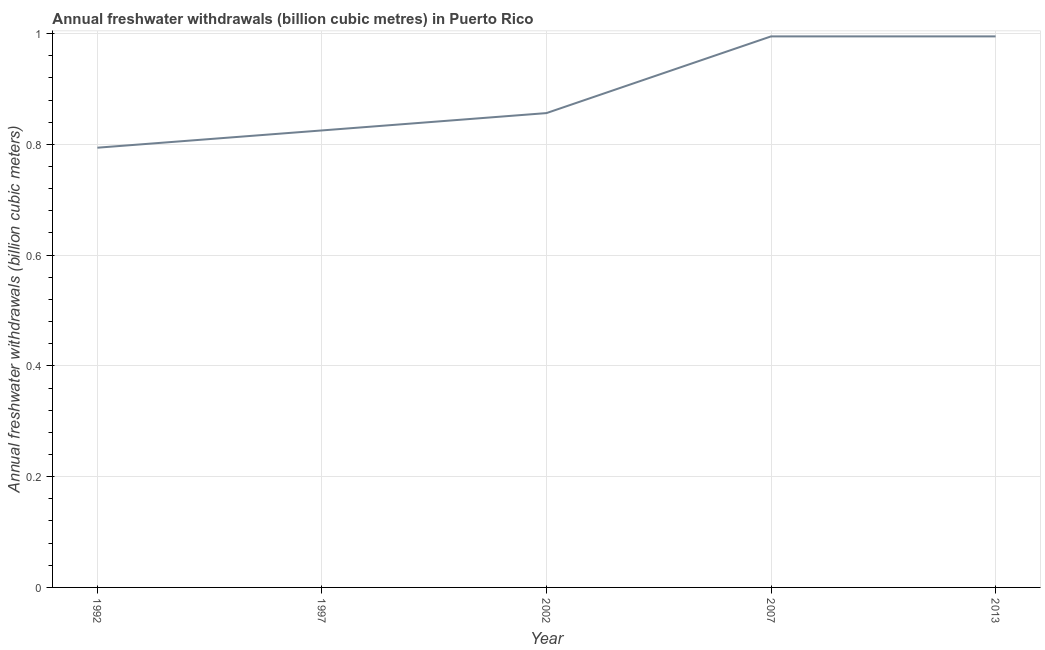What is the annual freshwater withdrawals in 1997?
Your answer should be very brief. 0.83. Across all years, what is the maximum annual freshwater withdrawals?
Offer a terse response. 0.99. Across all years, what is the minimum annual freshwater withdrawals?
Ensure brevity in your answer.  0.79. What is the sum of the annual freshwater withdrawals?
Give a very brief answer. 4.47. What is the difference between the annual freshwater withdrawals in 1992 and 2013?
Offer a terse response. -0.2. What is the average annual freshwater withdrawals per year?
Offer a very short reply. 0.89. What is the median annual freshwater withdrawals?
Offer a terse response. 0.86. In how many years, is the annual freshwater withdrawals greater than 0.7200000000000001 billion cubic meters?
Your answer should be very brief. 5. Do a majority of the years between 2013 and 2002 (inclusive) have annual freshwater withdrawals greater than 0.8400000000000001 billion cubic meters?
Offer a terse response. No. What is the ratio of the annual freshwater withdrawals in 1992 to that in 2013?
Give a very brief answer. 0.8. Is the annual freshwater withdrawals in 1997 less than that in 2002?
Your answer should be very brief. Yes. What is the difference between the highest and the second highest annual freshwater withdrawals?
Your response must be concise. 0. Is the sum of the annual freshwater withdrawals in 1992 and 2002 greater than the maximum annual freshwater withdrawals across all years?
Your answer should be very brief. Yes. What is the difference between the highest and the lowest annual freshwater withdrawals?
Keep it short and to the point. 0.2. In how many years, is the annual freshwater withdrawals greater than the average annual freshwater withdrawals taken over all years?
Your response must be concise. 2. Does the annual freshwater withdrawals monotonically increase over the years?
Your answer should be very brief. No. How many lines are there?
Offer a very short reply. 1. Does the graph contain any zero values?
Ensure brevity in your answer.  No. What is the title of the graph?
Provide a short and direct response. Annual freshwater withdrawals (billion cubic metres) in Puerto Rico. What is the label or title of the X-axis?
Make the answer very short. Year. What is the label or title of the Y-axis?
Give a very brief answer. Annual freshwater withdrawals (billion cubic meters). What is the Annual freshwater withdrawals (billion cubic meters) of 1992?
Ensure brevity in your answer.  0.79. What is the Annual freshwater withdrawals (billion cubic meters) in 1997?
Give a very brief answer. 0.83. What is the Annual freshwater withdrawals (billion cubic meters) of 2002?
Provide a succinct answer. 0.86. What is the Annual freshwater withdrawals (billion cubic meters) of 2007?
Your response must be concise. 0.99. What is the difference between the Annual freshwater withdrawals (billion cubic meters) in 1992 and 1997?
Ensure brevity in your answer.  -0.03. What is the difference between the Annual freshwater withdrawals (billion cubic meters) in 1992 and 2002?
Offer a terse response. -0.06. What is the difference between the Annual freshwater withdrawals (billion cubic meters) in 1992 and 2007?
Your answer should be compact. -0.2. What is the difference between the Annual freshwater withdrawals (billion cubic meters) in 1992 and 2013?
Provide a short and direct response. -0.2. What is the difference between the Annual freshwater withdrawals (billion cubic meters) in 1997 and 2002?
Your answer should be compact. -0.03. What is the difference between the Annual freshwater withdrawals (billion cubic meters) in 1997 and 2007?
Offer a very short reply. -0.17. What is the difference between the Annual freshwater withdrawals (billion cubic meters) in 1997 and 2013?
Make the answer very short. -0.17. What is the difference between the Annual freshwater withdrawals (billion cubic meters) in 2002 and 2007?
Your answer should be compact. -0.14. What is the difference between the Annual freshwater withdrawals (billion cubic meters) in 2002 and 2013?
Offer a terse response. -0.14. What is the difference between the Annual freshwater withdrawals (billion cubic meters) in 2007 and 2013?
Give a very brief answer. 0. What is the ratio of the Annual freshwater withdrawals (billion cubic meters) in 1992 to that in 1997?
Offer a terse response. 0.96. What is the ratio of the Annual freshwater withdrawals (billion cubic meters) in 1992 to that in 2002?
Your response must be concise. 0.93. What is the ratio of the Annual freshwater withdrawals (billion cubic meters) in 1992 to that in 2007?
Provide a succinct answer. 0.8. What is the ratio of the Annual freshwater withdrawals (billion cubic meters) in 1992 to that in 2013?
Your answer should be compact. 0.8. What is the ratio of the Annual freshwater withdrawals (billion cubic meters) in 1997 to that in 2007?
Your response must be concise. 0.83. What is the ratio of the Annual freshwater withdrawals (billion cubic meters) in 1997 to that in 2013?
Provide a succinct answer. 0.83. What is the ratio of the Annual freshwater withdrawals (billion cubic meters) in 2002 to that in 2007?
Provide a short and direct response. 0.86. What is the ratio of the Annual freshwater withdrawals (billion cubic meters) in 2002 to that in 2013?
Your answer should be very brief. 0.86. 